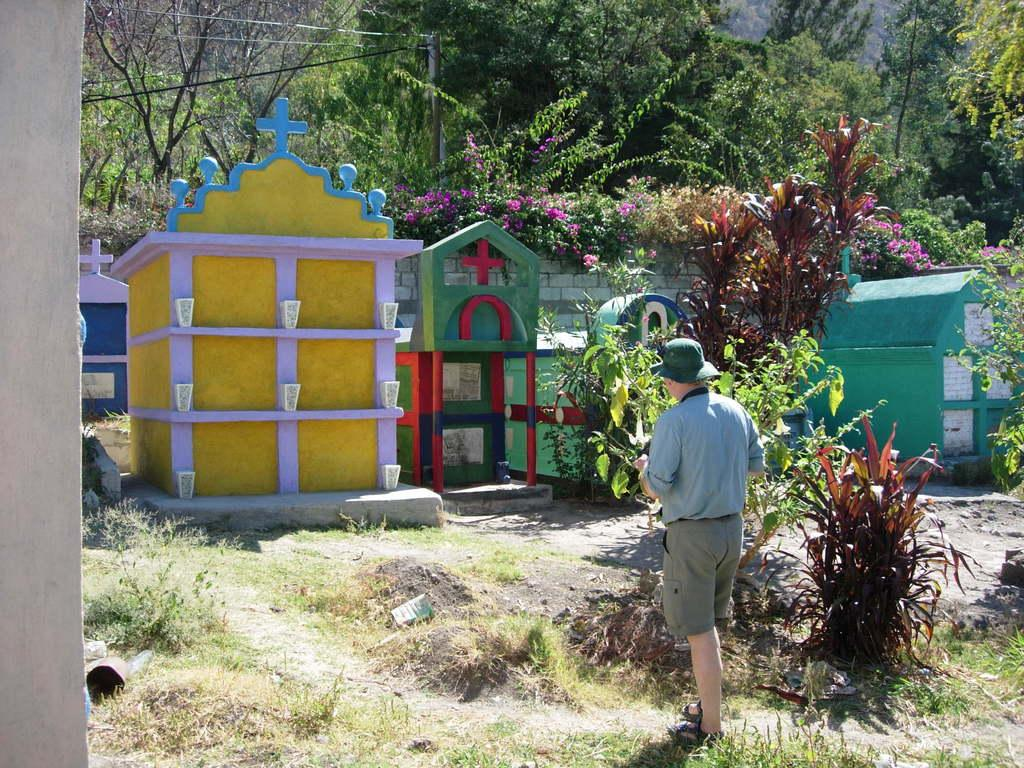What is the main subject of the image? There is a person standing on the ground in the image. What else can be seen on the ground in the image? There are plants and graves on the ground in the image. What is visible in the background of the image? There are trees visible in the background of the image. What type of brass instrument is being played by the person in the image? There is no brass instrument present in the image; the person is simply standing on the ground. What color are the stockings worn by the person in the image? There is no indication of the person wearing stockings in the image, so we cannot determine their color. 